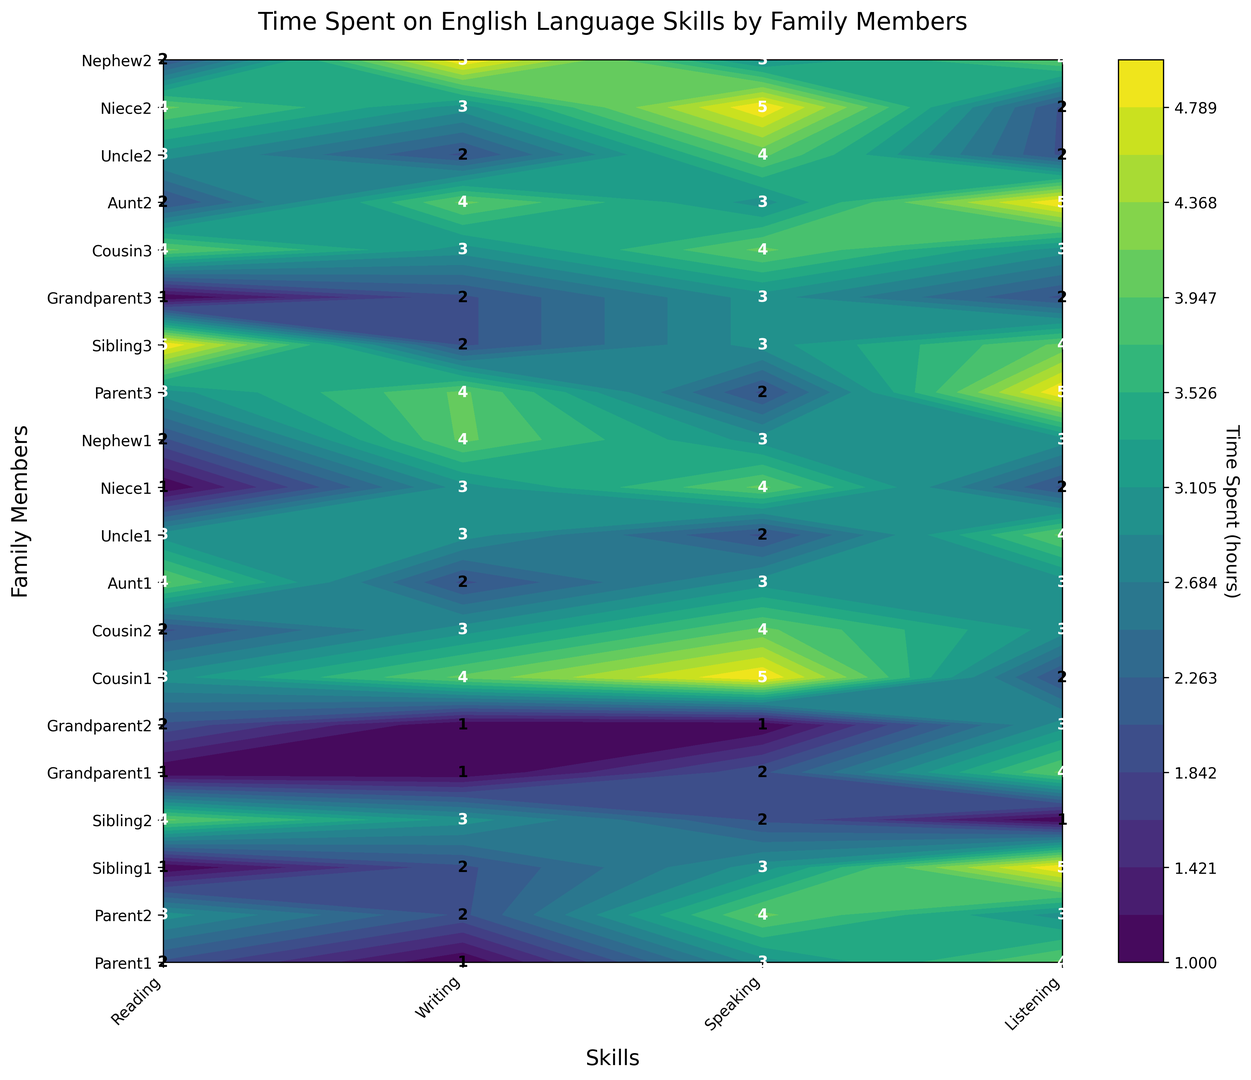What is the average time spent on reading by all family members? To find the average time, sum the reading times for all family members and divide by the number of family members. Sum of reading times is 2+3+1+4+1+2+3+2+4+3+1+2+3+5+1+4+2+3+4+2 = 49. There are 20 family members, so the average time spent on reading is 49/20 = 2.45
Answer: 2.45 Which family member spends the most and the least time on speaking? To find this, look at the "Speaking" column and identify the highest and lowest values. The highest value is 5 by Cousin1 and Niece2, the lowest is 1 by Grandparent2
Answer: Most: Cousin1, Niece2; Least: Grandparent2 What is the difference in time spent on listening between Parent1 and Sibling2? Look at the listening times for Parent1 and Sibling2. Parent1 spends 4 hours, and Sibling2 spends 1 hour. The difference is 4 - 1 = 3 hours
Answer: 3 Which skill has the most even distribution of time across all family members? Even distribution can be observed by looking at the contour colors. By visually inspecting, "Listening" seems to have the most balanced colors across family members without extreme highs and lows
Answer: Listening How many family members spend more than 3 hours on writing? Count the number of family members with writing time greater than 3. From the plot, Cousin1, Niece1, Nephew1, Parent3, Aunt2, Nephew2 have more than 3 hours. This counts to 6 members
Answer: 6 Which family member spends equal time on reading and listening? Find the instances where the values for reading and listening match. By inspecting the plot, Parent3 and Grandparent3 both spend equal (3 and 2 respectively)
Answer: Parent3, Grandparent3 Which skill does Niece1 spend the most and least time on? Check Niece1's values for all skills. Niece1 spends most on speaking (4 hours) and least on reading (1 hour)
Answer: Most: Speaking; Least: Reading What is the total time spent on speaking by all family members? Sum the speaking times for all family members: 3+4+3+2+2+1+5+4+3+2+4+3+2+3+3+4+3+4+3+3 = 61 hours
Answer: 61 Compare the average time spent on listening and reading by the entire family Calculate both averages: Sum of listening times is 4+3+5+1+4+3+2+3+3+4+2+3+5+4+2+3+5+2+4+4 = 62. Average is 62/20 = 3.1. Sum of reading times is 49. Average is 49/20 = 2.45. Compare these averages, 3.1 for listening and 2.45 for reading
Answer: Listening: 3.1, Reading: 2.45 